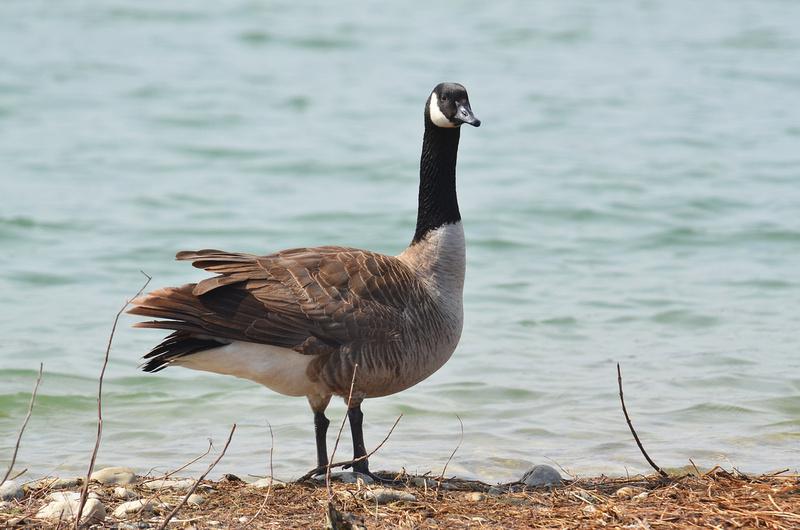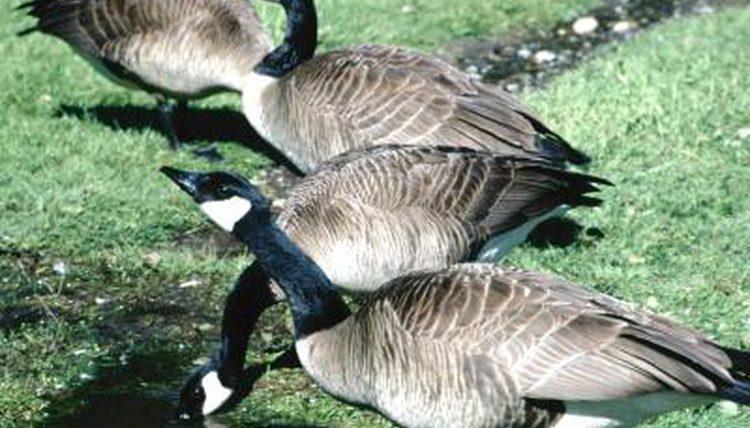The first image is the image on the left, the second image is the image on the right. Given the left and right images, does the statement "There are exactly two ducks." hold true? Answer yes or no. No. The first image is the image on the left, the second image is the image on the right. Evaluate the accuracy of this statement regarding the images: "An image shows one black-beaked goose standing on the water's edge.". Is it true? Answer yes or no. Yes. 